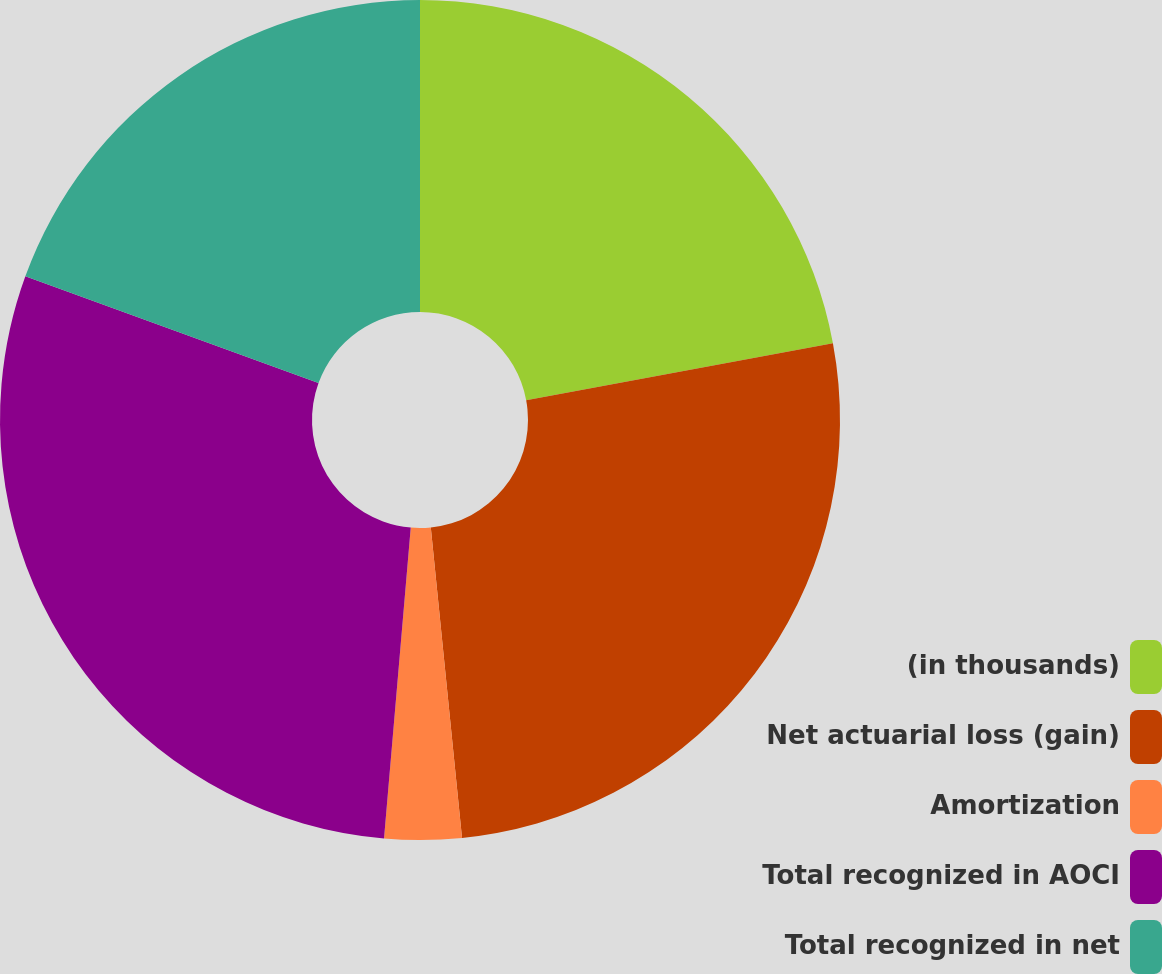Convert chart to OTSL. <chart><loc_0><loc_0><loc_500><loc_500><pie_chart><fcel>(in thousands)<fcel>Net actuarial loss (gain)<fcel>Amortization<fcel>Total recognized in AOCI<fcel>Total recognized in net<nl><fcel>22.07%<fcel>26.33%<fcel>2.96%<fcel>29.19%<fcel>19.44%<nl></chart> 